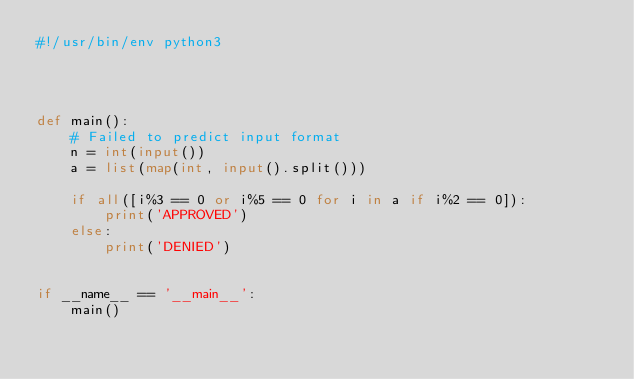<code> <loc_0><loc_0><loc_500><loc_500><_Python_>#!/usr/bin/env python3




def main():
    # Failed to predict input format
    n = int(input())
    a = list(map(int, input().split()))

    if all([i%3 == 0 or i%5 == 0 for i in a if i%2 == 0]):
        print('APPROVED')
    else:
        print('DENIED')
    

if __name__ == '__main__':
    main()
</code> 